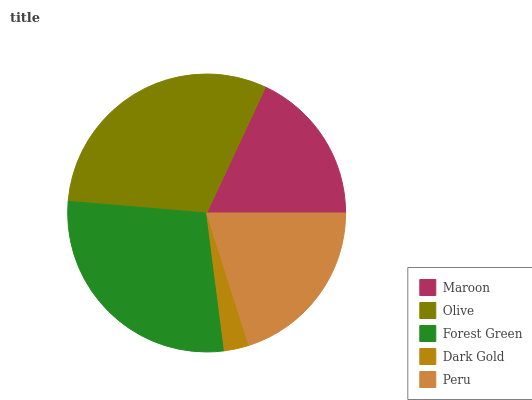Is Dark Gold the minimum?
Answer yes or no. Yes. Is Olive the maximum?
Answer yes or no. Yes. Is Forest Green the minimum?
Answer yes or no. No. Is Forest Green the maximum?
Answer yes or no. No. Is Olive greater than Forest Green?
Answer yes or no. Yes. Is Forest Green less than Olive?
Answer yes or no. Yes. Is Forest Green greater than Olive?
Answer yes or no. No. Is Olive less than Forest Green?
Answer yes or no. No. Is Peru the high median?
Answer yes or no. Yes. Is Peru the low median?
Answer yes or no. Yes. Is Maroon the high median?
Answer yes or no. No. Is Forest Green the low median?
Answer yes or no. No. 